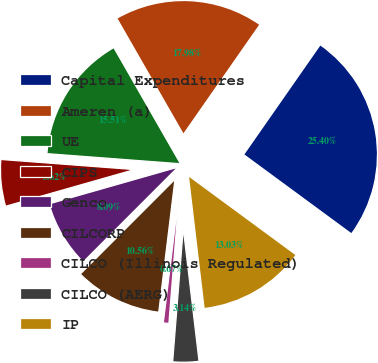<chart> <loc_0><loc_0><loc_500><loc_500><pie_chart><fcel>Capital Expenditures<fcel>Ameren (a)<fcel>UE<fcel>CIPS<fcel>Genco<fcel>CILCORP<fcel>CILCO (Illinois Regulated)<fcel>CILCO (AERG)<fcel>IP<nl><fcel>25.4%<fcel>17.98%<fcel>15.51%<fcel>5.62%<fcel>8.09%<fcel>10.56%<fcel>0.67%<fcel>3.14%<fcel>13.03%<nl></chart> 